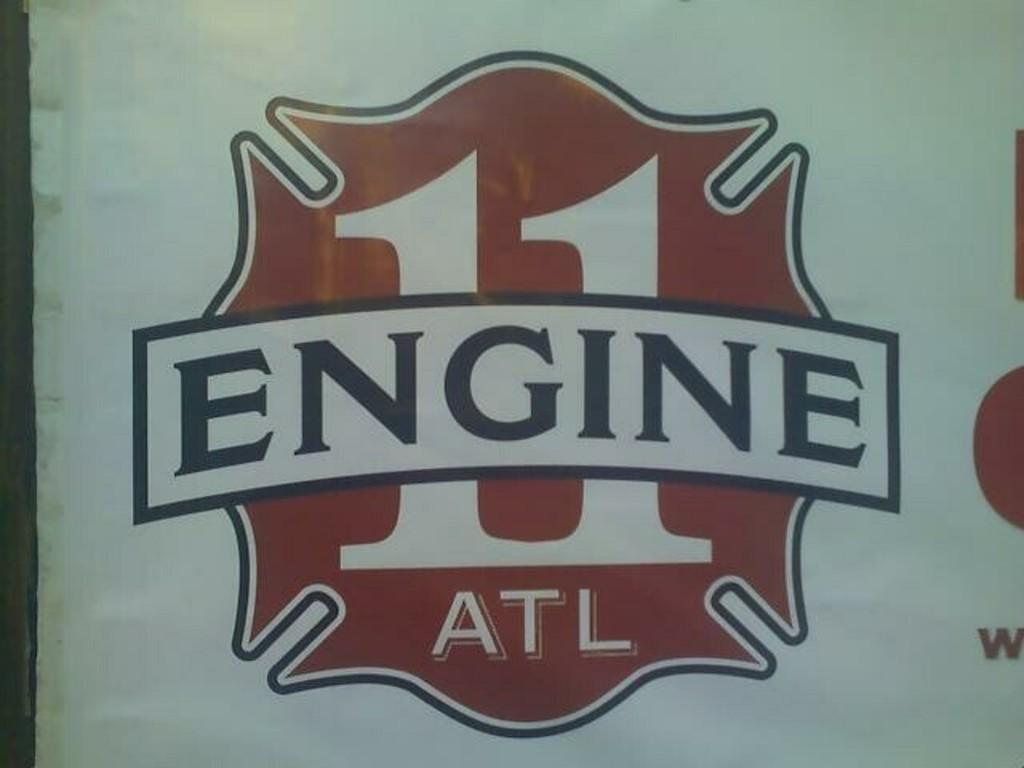<image>
Provide a brief description of the given image. A symbol says Engine 11 ATL on a white background. 